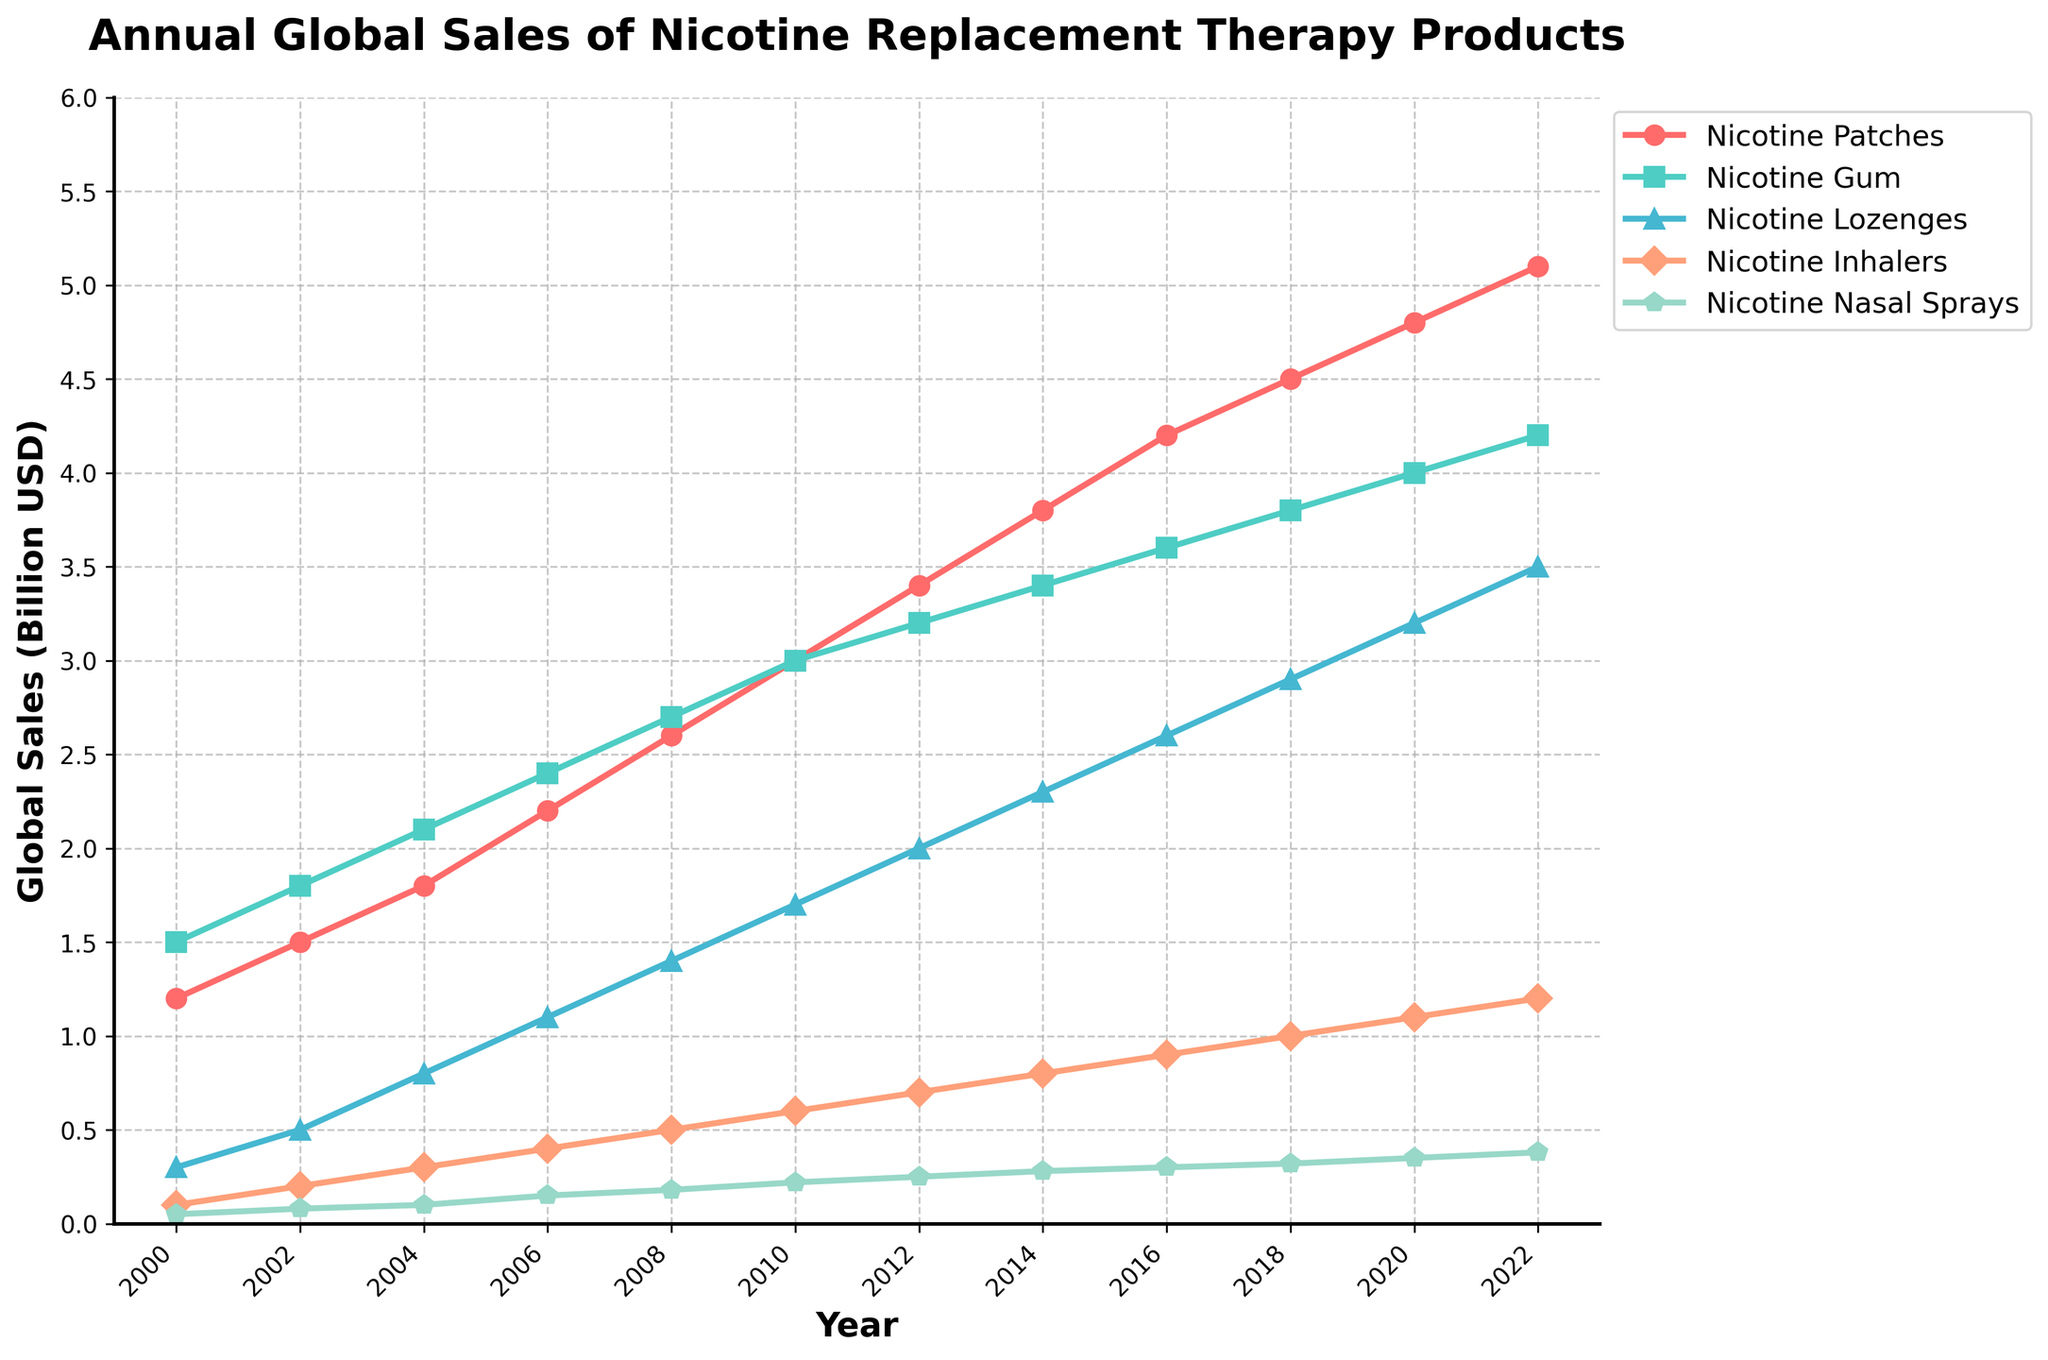What year did Nicotine Patches first reach sales of 4 billion USD? By observing the Nicotine Patches line, we see that it reaches the 4 billion USD mark in the year 2016.
Answer: 2016 Which product type had the highest global sales in 2022? By looking at the end of the lines in 2022, Nicotine Patches have the highest value (5.1 billion USD).
Answer: Nicotine Patches How much did sales for Nicotine Gum increase from 2000 to 2022? In 2000, Nicotine Gum sales were 1.5 billion USD. By 2022, they were 4.2 billion USD. The increase is 4.2 - 1.5 = 2.7 billion USD.
Answer: 2.7 billion USD Which product type had the least growth from 2000 to 2022? Comparing the growth of all products: Nicotine Nasal Sprays had sales of 0.05 billion USD in 2000 and 0.38 billion USD in 2022. The increase is just 0.33 billion USD, which is the smallest compared to other products.
Answer: Nicotine Nasal Sprays What is the average annual sales of Nicotine Lozenges over the whole period? Summing the sales of Nicotine Lozenges at each year and dividing by the number of years gives: (0.3 + 0.5 + 0.8 + 1.1 + 1.4 + 1.7 + 2.0 + 2.3 + 2.6 + 2.9 + 3.2 + 3.5) / 12 = 17.3 / 12 ≈ 1.44 billion USD
Answer: 1.44 billion USD Which year saw the largest one-year increase in sales for Nicotine Patches? Looking at the Nicotine Patches' data points year-by-year, the largest increase happens between 2012 and 2014, where it goes from 3.4 to 3.8 billion USD, an increase of 0.4 billion USD.
Answer: 2014 In 2018, which product had higher sales: Nicotine Inhalers or Nicotine Lozenges? Observing the 2018 sales values, Nicotine Lozenges had 2.9 billion USD while Nicotine Inhalers had 1.0 billion USD. Therefore, Nicotine Lozenges had higher sales.
Answer: Nicotine Lozenges What is the total sales of all nicotine products in 2010? Summing the sales of all products in 2010 results in: 3.0 (Patches) + 3.0 (Gum) + 1.7 (Lozenges) + 0.6 (Inhalers) + 0.22 (Nasal Sprays) = 8.52 billion USD
Answer: 8.52 billion USD By how much did the sales of Nicotine Inhalers grow from 2000 to 2008? The sales of Nicotine Inhalers grew from 0.1 billion USD in 2000 to 0.5 billion USD in 2008. The increase is 0.5 - 0.1 = 0.4 billion USD.
Answer: 0.4 billion USD 